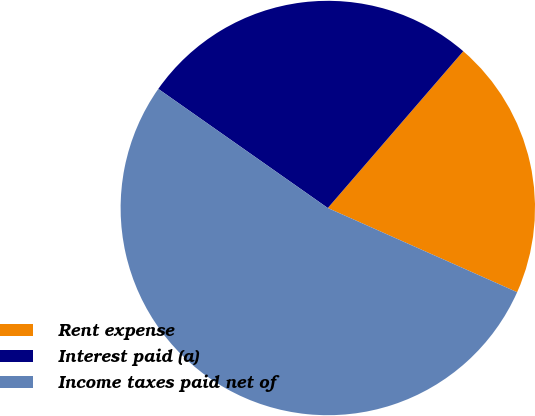Convert chart to OTSL. <chart><loc_0><loc_0><loc_500><loc_500><pie_chart><fcel>Rent expense<fcel>Interest paid (a)<fcel>Income taxes paid net of<nl><fcel>20.32%<fcel>26.59%<fcel>53.09%<nl></chart> 